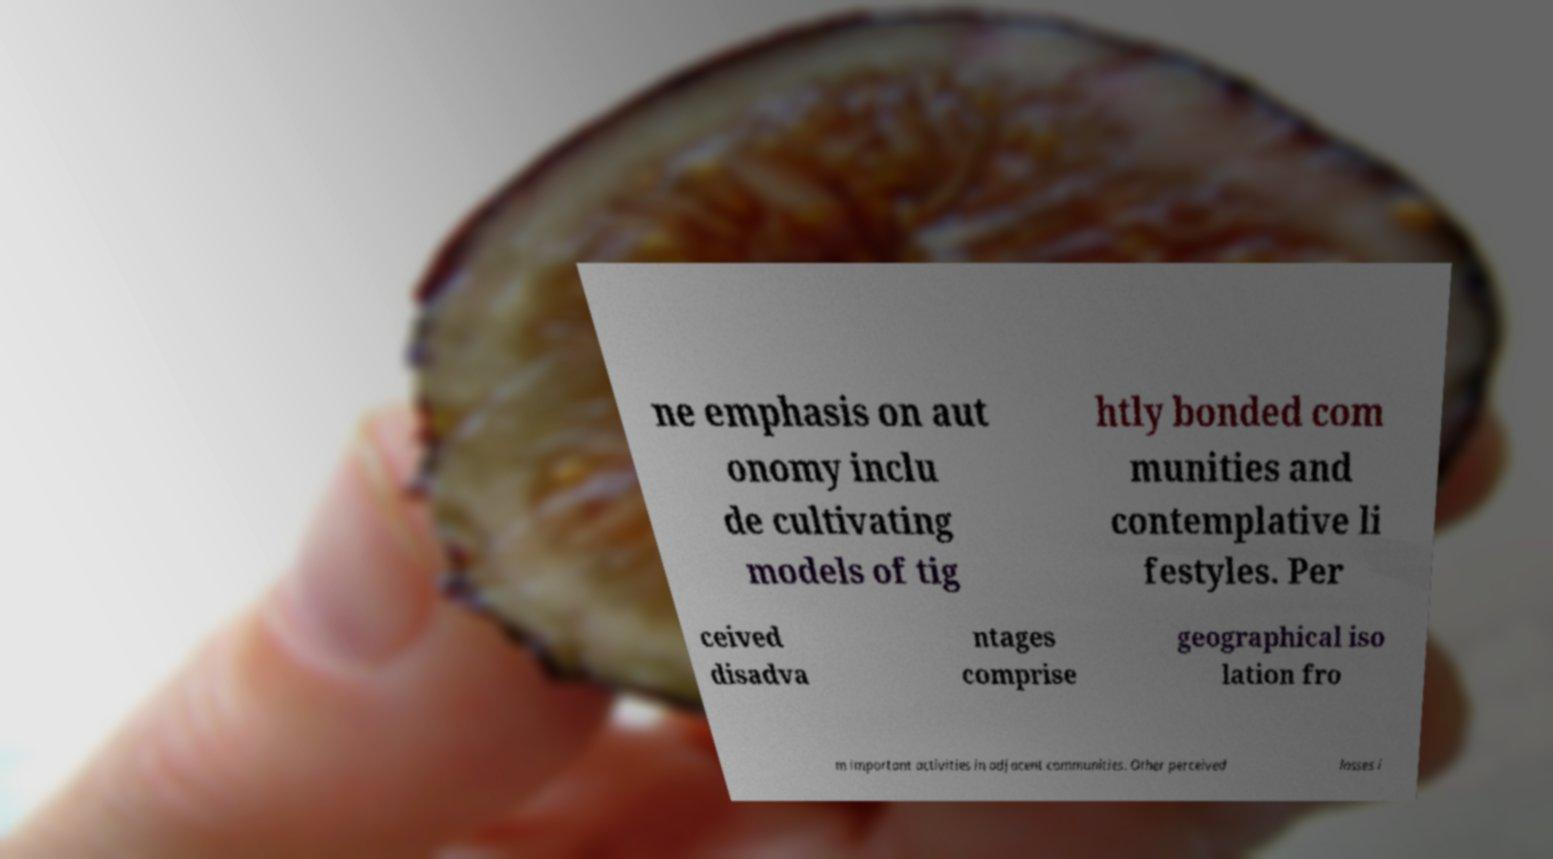For documentation purposes, I need the text within this image transcribed. Could you provide that? ne emphasis on aut onomy inclu de cultivating models of tig htly bonded com munities and contemplative li festyles. Per ceived disadva ntages comprise geographical iso lation fro m important activities in adjacent communities. Other perceived losses i 